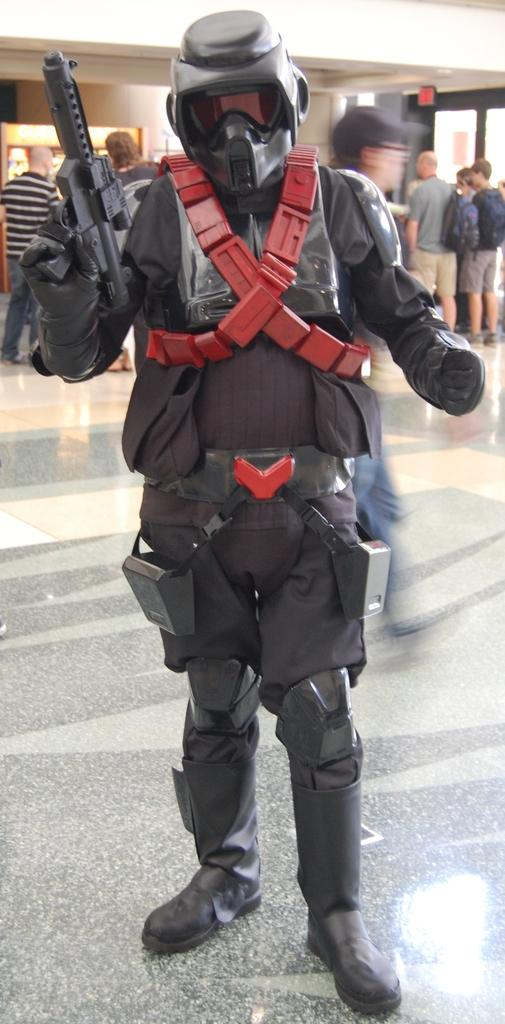What is the person in the image wearing on their head? The person is wearing a helmet in the image. What is the person holding in their hands? The person is holding a gun in the image. Can you describe the people standing behind the person with helmets? The people behind the person are wearing bags. What is visible on the roof in the image? There are lights on the roof in the image. What type of floor can be seen in the image? There is no information about the floor in the image, as the focus is on the people and their equipment. 